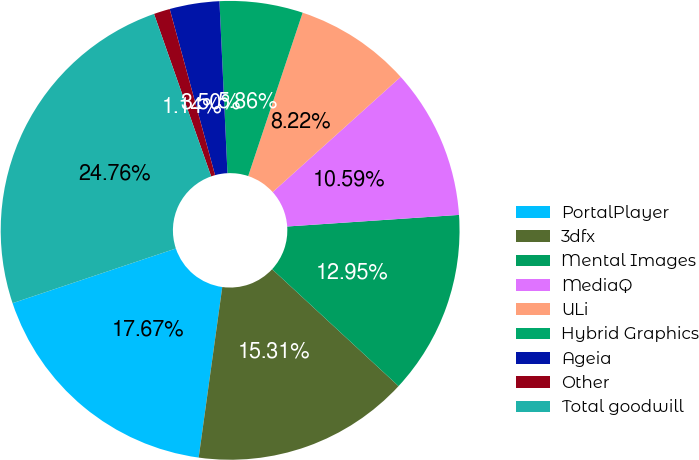Convert chart to OTSL. <chart><loc_0><loc_0><loc_500><loc_500><pie_chart><fcel>PortalPlayer<fcel>3dfx<fcel>Mental Images<fcel>MediaQ<fcel>ULi<fcel>Hybrid Graphics<fcel>Ageia<fcel>Other<fcel>Total goodwill<nl><fcel>17.67%<fcel>15.31%<fcel>12.95%<fcel>10.59%<fcel>8.22%<fcel>5.86%<fcel>3.5%<fcel>1.14%<fcel>24.76%<nl></chart> 